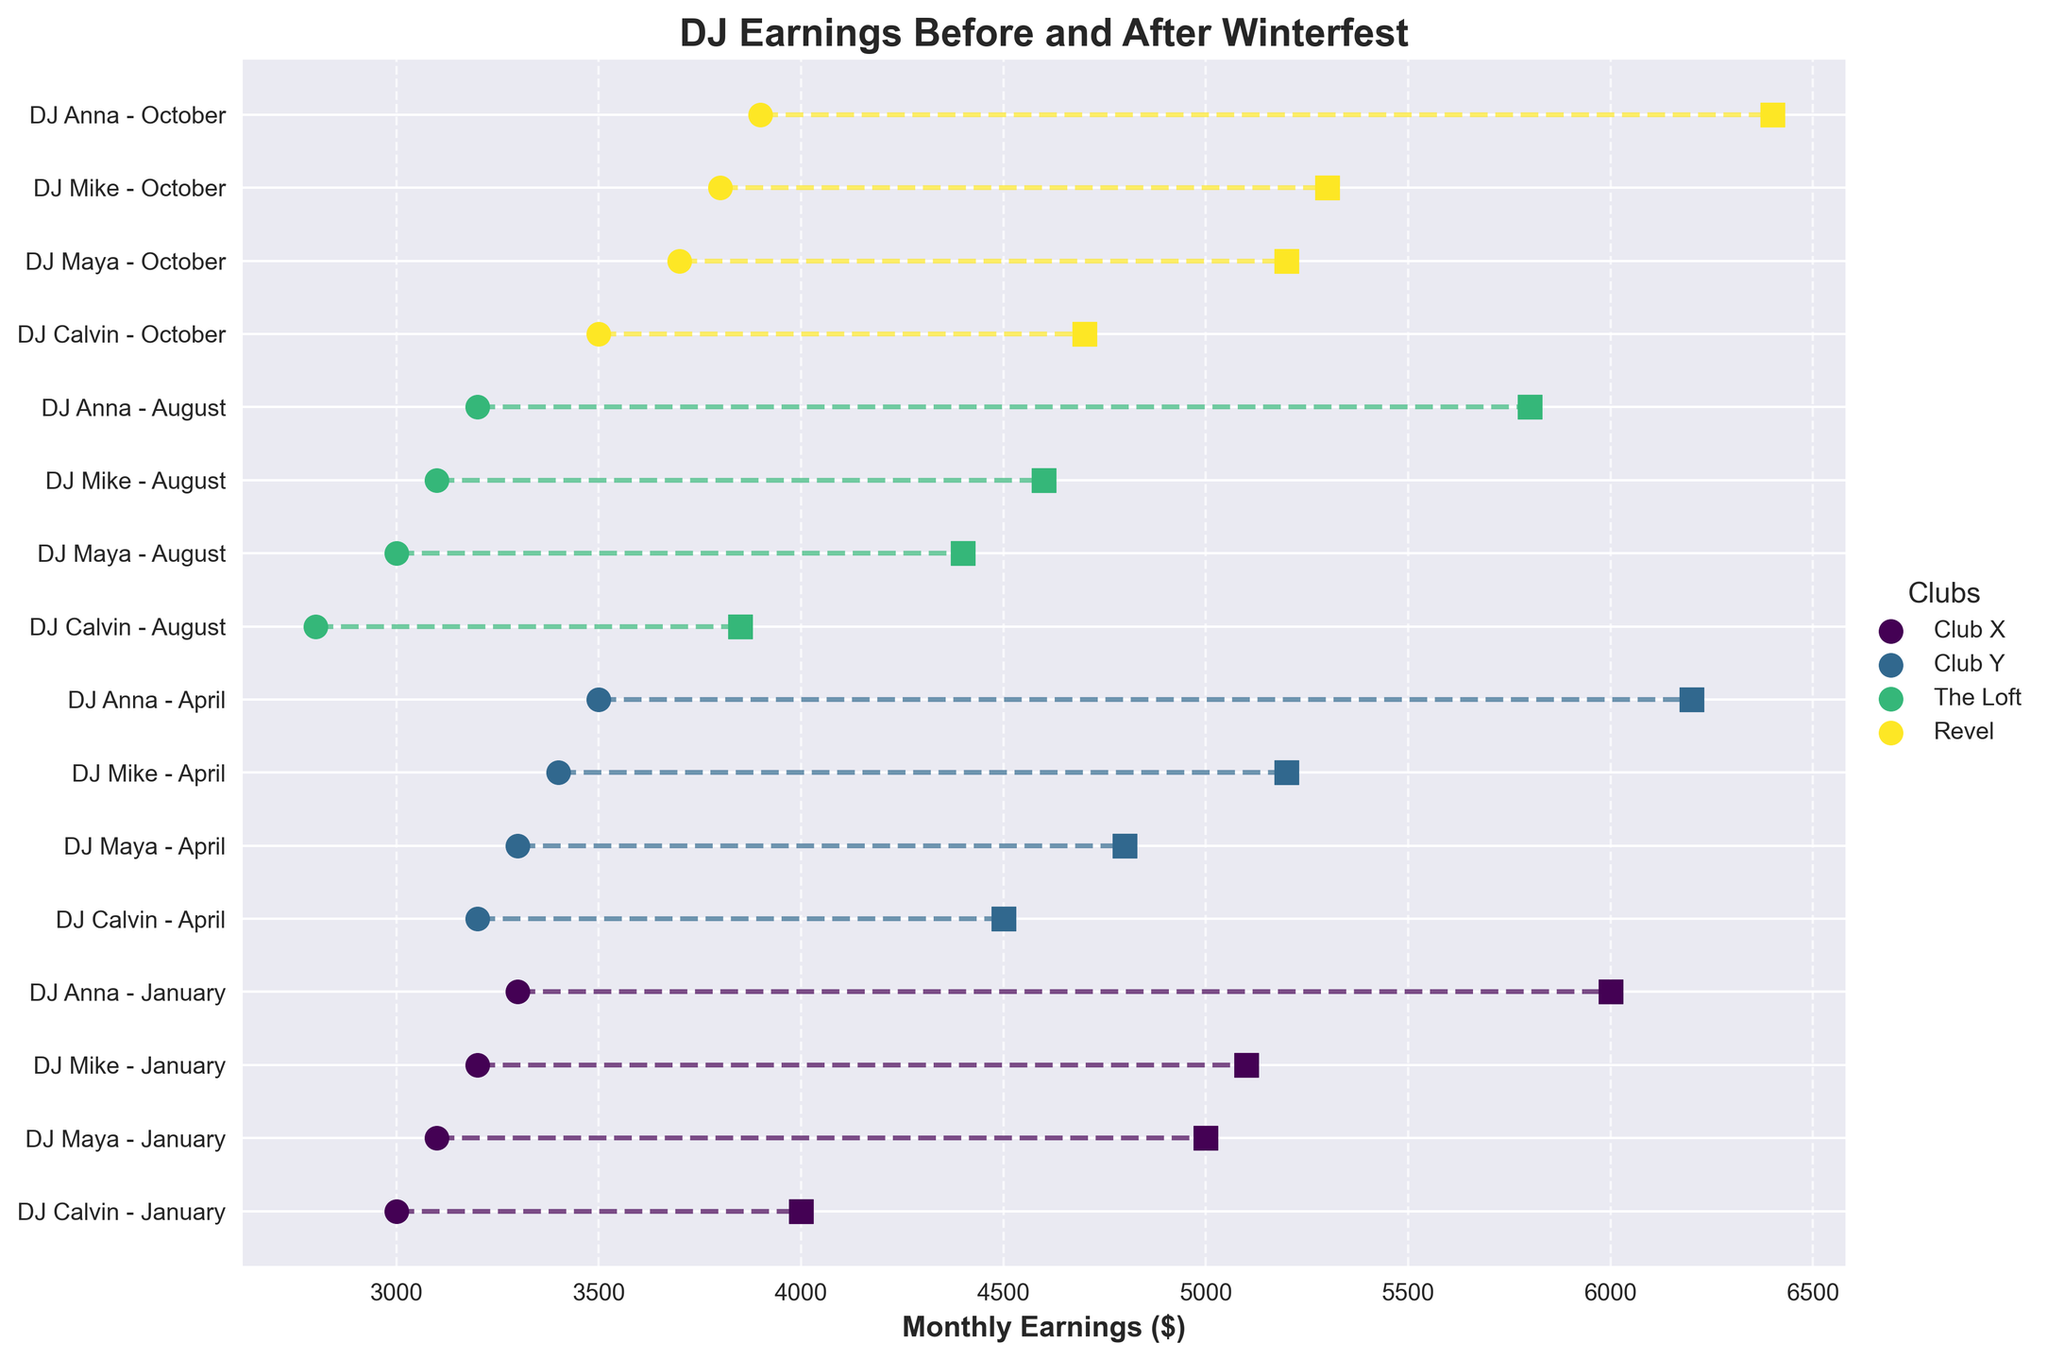How many DJs are featured in the plot? Count the unique DJs labeled on the y-axis. There are 4 DJs: DJ Calvin, DJ Maya, DJ Mike, and DJ Anna.
Answer: 4 What is the title of the plot? Look at the top of the plot where the title is located. The title is "DJ Earnings Before and After Winterfest."
Answer: DJ Earnings Before and After Winterfest Which club had the highest earnings increase after Winterfest in October? Check the end of the lines in October for each DJ and club, then find the highest post-Winterfest value. Club Revel with DJ Anna had the earnings increase to $6400, the highest among the clubs.
Answer: Club Revel What is the difference in earnings for DJ Calvin at Club X before and after Winterfest in April? Check the before and after earnings values for DJ Calvin in April. Subtract the before value ($3100) from the after value ($5000): $5000 - $3100 = $1900.
Answer: $1900 Which DJ had the smallest increase in earnings after Winterfest in January? Compare the earnings increases for each DJ in January. The smallest increase is for DJ Mike at The Loft, from $2800 to $3850, an increase of $1050.
Answer: DJ Mike What is the average earnings of DJ Anna before Winterfest across all months? Calculate the mean of DJ Anna's before Winterfest values: ($3500 + $3700 + $3800 + $3900) / 4 = $3725.
Answer: $3725 Which month shows the greatest earnings increase for DJ Maya after Winterfest? Check DJ Maya's earnings before and after Winterfest for each month and find the greatest increase. October shows the largest increase from $3500 to $6200, which is $2700.
Answer: October For which month do all DJs show an increase in earnings after Winterfest, and what are the smallest and largest earnings increases that month? Check each DJ's earnings before and after Winterfest for each month. In October, all DJs show an increase. The smallest increase is DJ Calvin (from $3300 to $6000 = $2700), and the largest is DJ Maya (from $3500 to $6200 = $2700).
Answer: October, $2700, $2700 How do the earnings of DJs in Club Y before Winterfest in January compare to those in Club X before Winterfest in January? Compare DJ Maya's (Club Y) and DJ Calvin's (Club X) earnings before Winterfest in January. DJ Maya at Club Y earned $3200, while DJ Calvin at Club X earned $3000. DJ Maya's earnings were higher by $200.
Answer: DJ Maya's earnings were $200 higher 